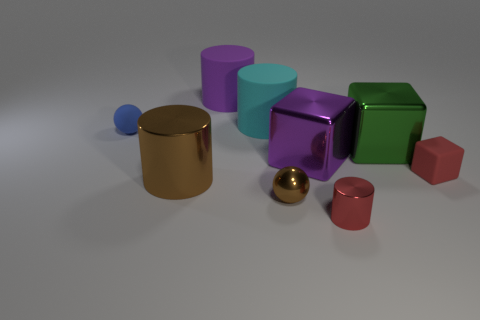How many other objects are the same shape as the small blue thing?
Offer a very short reply. 1. What is the shape of the rubber thing that is in front of the blue thing?
Provide a short and direct response. Cube. There is a tiny rubber thing on the right side of the big metallic object that is in front of the tiny red cube; what color is it?
Keep it short and to the point. Red. There is another shiny object that is the same shape as the green shiny thing; what color is it?
Offer a very short reply. Purple. What number of matte things are the same color as the small matte ball?
Keep it short and to the point. 0. There is a tiny metal cylinder; does it have the same color as the tiny matte object that is to the right of the red cylinder?
Ensure brevity in your answer.  Yes. There is a object that is to the left of the big purple rubber cylinder and in front of the small blue rubber thing; what shape is it?
Give a very brief answer. Cylinder. What material is the purple thing in front of the tiny blue rubber sphere that is in front of the large cyan rubber cylinder that is behind the small red rubber block?
Your answer should be compact. Metal. Is the number of blue spheres that are on the left side of the tiny brown ball greater than the number of purple cylinders in front of the large purple metallic block?
Your answer should be very brief. Yes. What number of purple cylinders are made of the same material as the tiny red block?
Make the answer very short. 1. 